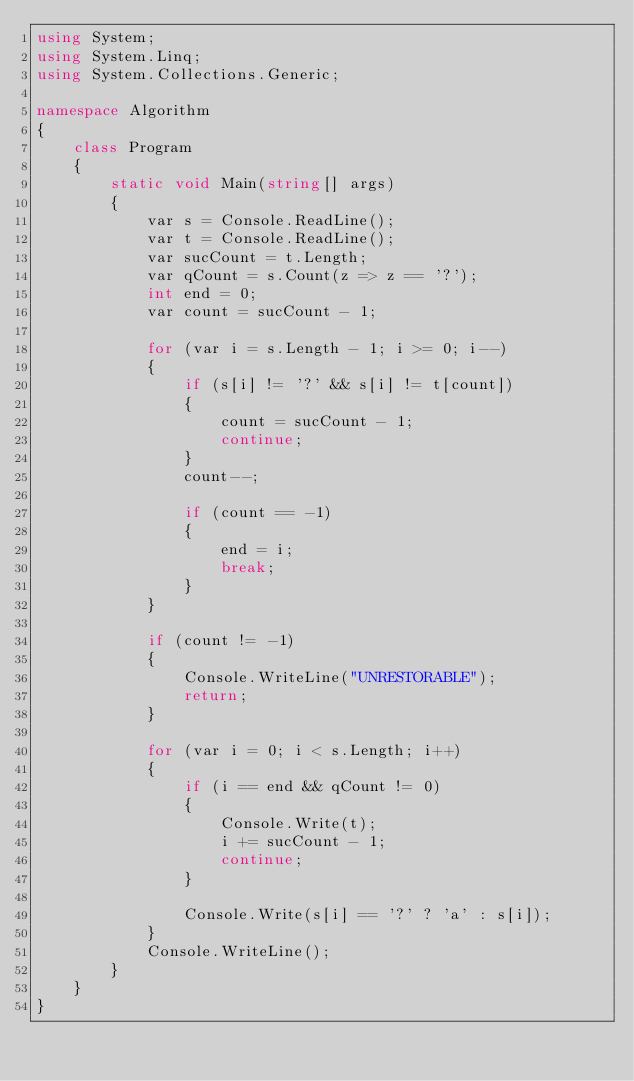Convert code to text. <code><loc_0><loc_0><loc_500><loc_500><_C#_>using System;
using System.Linq;
using System.Collections.Generic;

namespace Algorithm
{
    class Program
    {
        static void Main(string[] args)
        {
            var s = Console.ReadLine();
            var t = Console.ReadLine();
            var sucCount = t.Length;
            var qCount = s.Count(z => z == '?');
            int end = 0;
            var count = sucCount - 1;

            for (var i = s.Length - 1; i >= 0; i--)
            {
                if (s[i] != '?' && s[i] != t[count])
                {
                    count = sucCount - 1;
                    continue;
                }
                count--;

                if (count == -1)
                {
                    end = i;
                    break;
                }
            }
            
            if (count != -1)
            {
                Console.WriteLine("UNRESTORABLE");
                return;
            }

            for (var i = 0; i < s.Length; i++)
            {
                if (i == end && qCount != 0)
                {
                    Console.Write(t);
                    i += sucCount - 1;
                    continue;
                }

                Console.Write(s[i] == '?' ? 'a' : s[i]);
            }
            Console.WriteLine();
        }
    }
}
</code> 